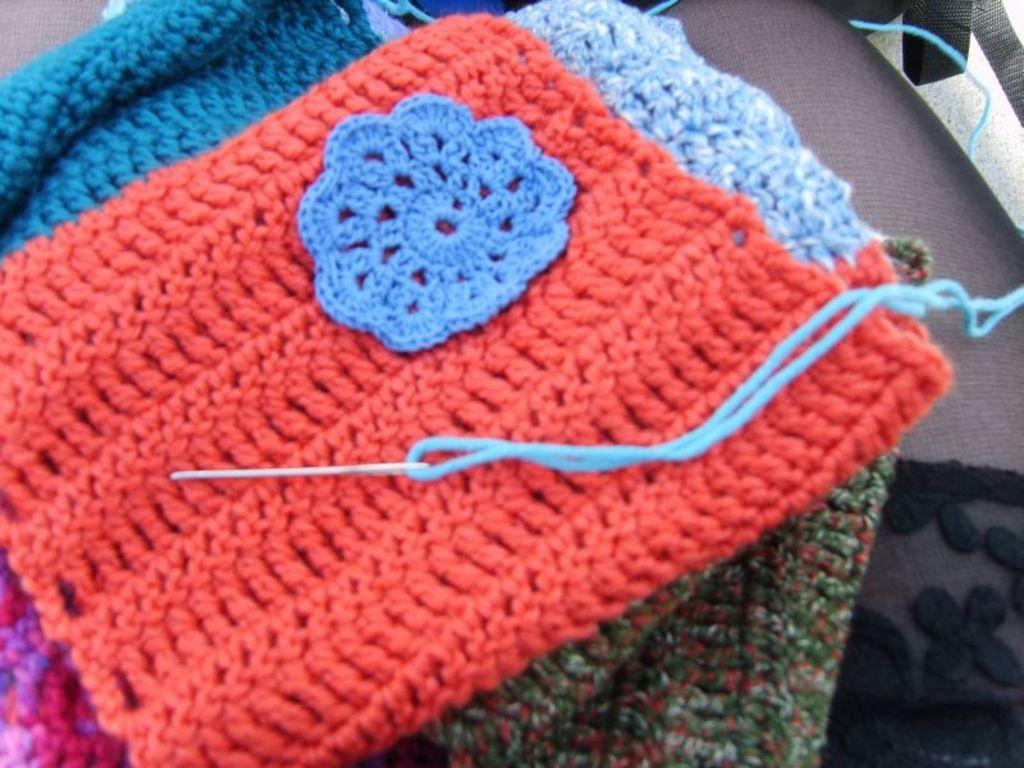What type of clothes are visible in the image? There are woolen clothes in the image. Where are the woolen clothes located? The woolen clothes are placed on a table. What is the topic of the discussion happening around the woolen clothes in the image? There is no discussion happening around the woolen clothes in the image. 